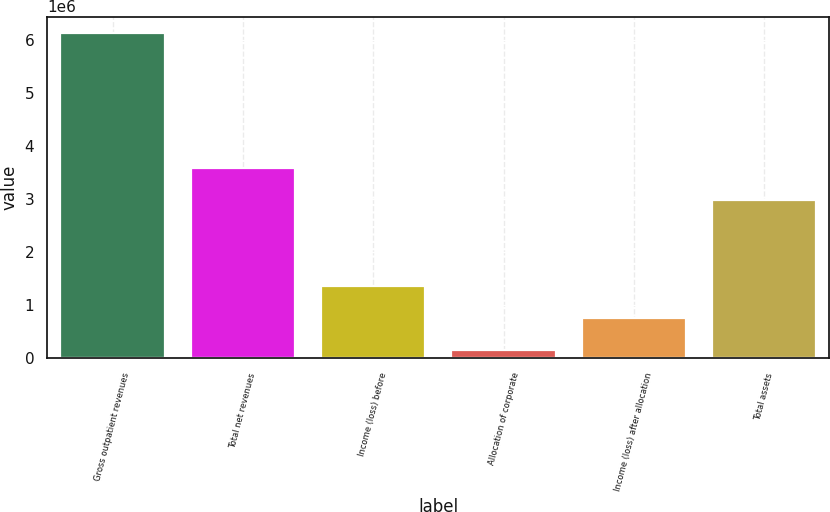<chart> <loc_0><loc_0><loc_500><loc_500><bar_chart><fcel>Gross outpatient revenues<fcel>Total net revenues<fcel>Income (loss) before<fcel>Allocation of corporate<fcel>Income (loss) after allocation<fcel>Total assets<nl><fcel>6.13462e+06<fcel>3.58142e+06<fcel>1.35657e+06<fcel>162056<fcel>759312<fcel>2.98417e+06<nl></chart> 